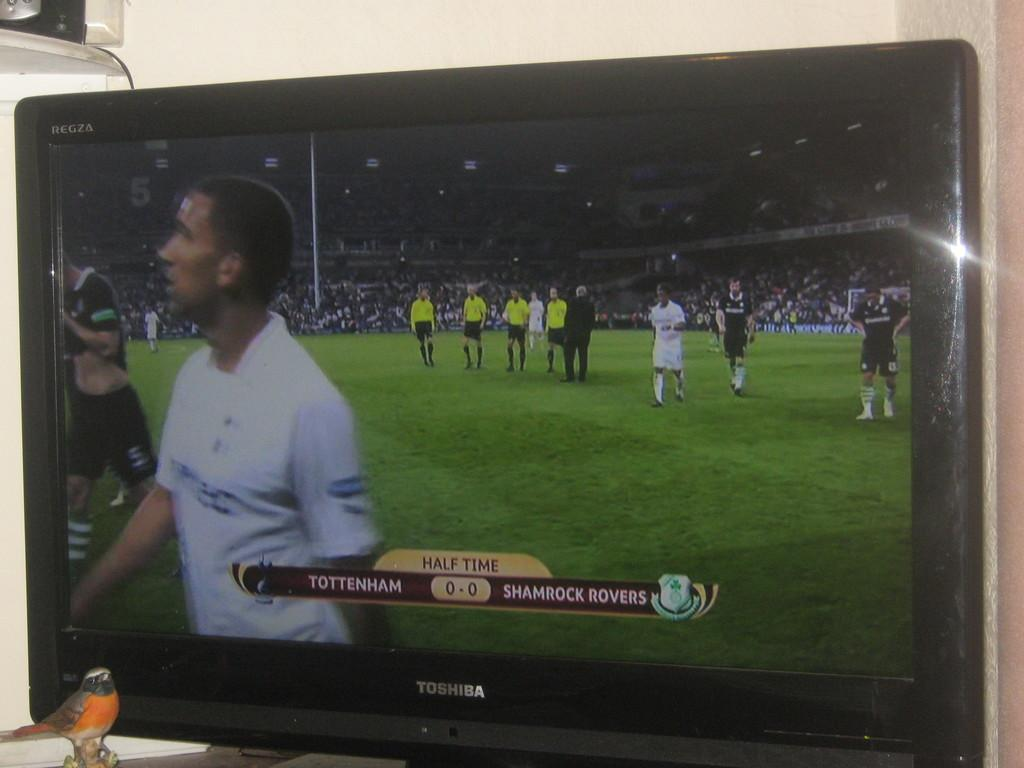<image>
Give a short and clear explanation of the subsequent image. A TV with a soccer match at half time on it 